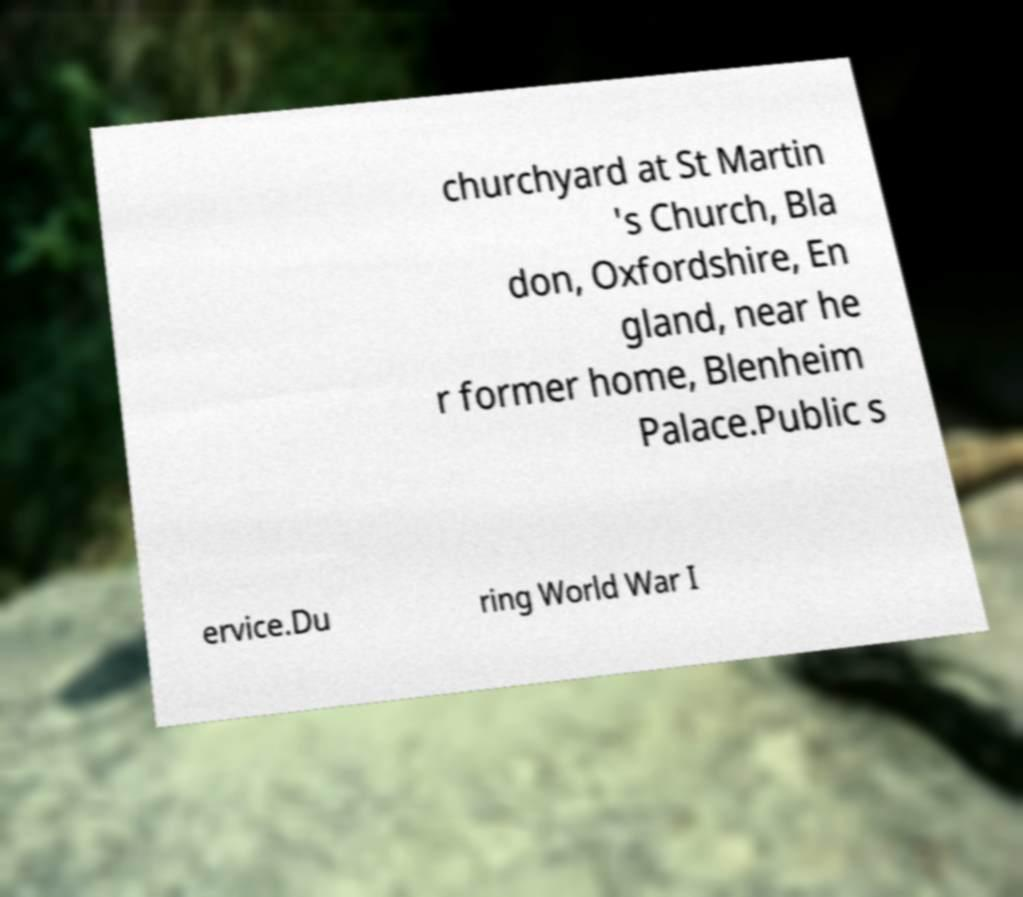Could you assist in decoding the text presented in this image and type it out clearly? churchyard at St Martin 's Church, Bla don, Oxfordshire, En gland, near he r former home, Blenheim Palace.Public s ervice.Du ring World War I 